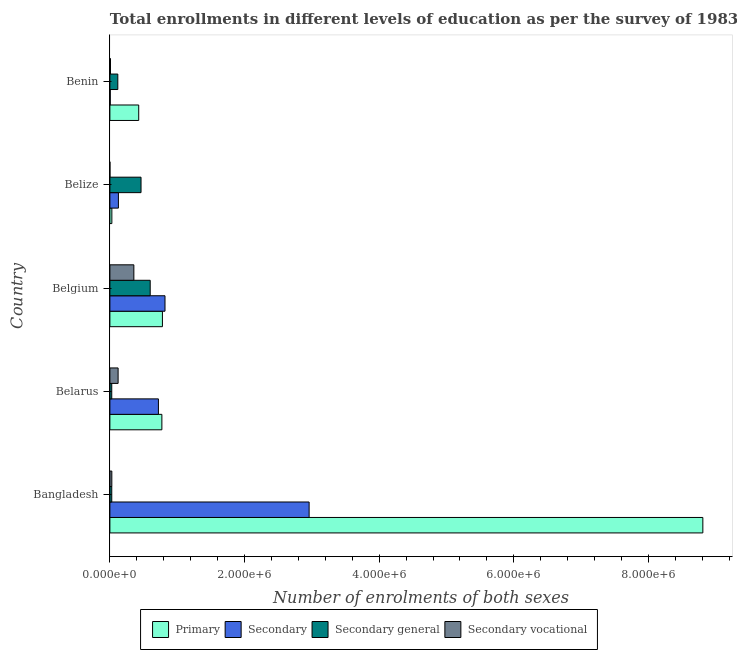Are the number of bars per tick equal to the number of legend labels?
Your answer should be compact. Yes. How many bars are there on the 3rd tick from the bottom?
Make the answer very short. 4. What is the label of the 4th group of bars from the top?
Offer a very short reply. Belarus. In how many cases, is the number of bars for a given country not equal to the number of legend labels?
Offer a terse response. 0. What is the number of enrolments in secondary education in Belgium?
Offer a very short reply. 8.19e+05. Across all countries, what is the maximum number of enrolments in secondary education?
Your answer should be very brief. 2.96e+06. Across all countries, what is the minimum number of enrolments in primary education?
Your answer should be compact. 2.91e+04. In which country was the number of enrolments in secondary general education maximum?
Give a very brief answer. Belgium. In which country was the number of enrolments in secondary education minimum?
Your answer should be compact. Benin. What is the total number of enrolments in secondary general education in the graph?
Offer a very short reply. 1.23e+06. What is the difference between the number of enrolments in secondary general education in Belize and that in Benin?
Ensure brevity in your answer.  3.45e+05. What is the difference between the number of enrolments in primary education in Bangladesh and the number of enrolments in secondary vocational education in Belgium?
Give a very brief answer. 8.45e+06. What is the average number of enrolments in secondary general education per country?
Make the answer very short. 2.47e+05. What is the difference between the number of enrolments in secondary vocational education and number of enrolments in primary education in Belize?
Provide a succinct answer. -2.89e+04. In how many countries, is the number of enrolments in secondary general education greater than 6800000 ?
Give a very brief answer. 0. What is the ratio of the number of enrolments in primary education in Bangladesh to that in Belize?
Make the answer very short. 302.47. Is the number of enrolments in secondary vocational education in Bangladesh less than that in Belarus?
Your answer should be compact. Yes. What is the difference between the highest and the second highest number of enrolments in secondary vocational education?
Make the answer very short. 2.34e+05. What is the difference between the highest and the lowest number of enrolments in secondary education?
Your answer should be very brief. 2.95e+06. In how many countries, is the number of enrolments in secondary vocational education greater than the average number of enrolments in secondary vocational education taken over all countries?
Ensure brevity in your answer.  2. Is the sum of the number of enrolments in secondary general education in Belgium and Benin greater than the maximum number of enrolments in primary education across all countries?
Offer a very short reply. No. Is it the case that in every country, the sum of the number of enrolments in secondary vocational education and number of enrolments in primary education is greater than the sum of number of enrolments in secondary education and number of enrolments in secondary general education?
Your answer should be very brief. No. What does the 4th bar from the top in Belgium represents?
Provide a short and direct response. Primary. What does the 3rd bar from the bottom in Belize represents?
Your response must be concise. Secondary general. Is it the case that in every country, the sum of the number of enrolments in primary education and number of enrolments in secondary education is greater than the number of enrolments in secondary general education?
Your answer should be very brief. No. How many countries are there in the graph?
Give a very brief answer. 5. What is the difference between two consecutive major ticks on the X-axis?
Offer a terse response. 2.00e+06. Does the graph contain any zero values?
Provide a short and direct response. No. How many legend labels are there?
Give a very brief answer. 4. What is the title of the graph?
Ensure brevity in your answer.  Total enrollments in different levels of education as per the survey of 1983. Does "Labor Taxes" appear as one of the legend labels in the graph?
Give a very brief answer. No. What is the label or title of the X-axis?
Offer a very short reply. Number of enrolments of both sexes. What is the Number of enrolments of both sexes of Primary in Bangladesh?
Your answer should be very brief. 8.81e+06. What is the Number of enrolments of both sexes in Secondary in Bangladesh?
Offer a terse response. 2.96e+06. What is the Number of enrolments of both sexes of Secondary general in Bangladesh?
Provide a succinct answer. 2.78e+04. What is the Number of enrolments of both sexes in Secondary vocational in Bangladesh?
Keep it short and to the point. 2.87e+04. What is the Number of enrolments of both sexes in Primary in Belarus?
Make the answer very short. 7.72e+05. What is the Number of enrolments of both sexes in Secondary in Belarus?
Offer a terse response. 7.21e+05. What is the Number of enrolments of both sexes in Secondary general in Belarus?
Provide a short and direct response. 2.76e+04. What is the Number of enrolments of both sexes in Secondary vocational in Belarus?
Your answer should be very brief. 1.22e+05. What is the Number of enrolments of both sexes of Primary in Belgium?
Your answer should be very brief. 7.80e+05. What is the Number of enrolments of both sexes of Secondary in Belgium?
Offer a terse response. 8.19e+05. What is the Number of enrolments of both sexes in Secondary general in Belgium?
Your answer should be compact. 5.99e+05. What is the Number of enrolments of both sexes of Secondary vocational in Belgium?
Make the answer very short. 3.56e+05. What is the Number of enrolments of both sexes of Primary in Belize?
Your answer should be compact. 2.91e+04. What is the Number of enrolments of both sexes of Secondary in Belize?
Provide a succinct answer. 1.26e+05. What is the Number of enrolments of both sexes in Secondary general in Belize?
Provide a succinct answer. 4.62e+05. What is the Number of enrolments of both sexes in Secondary vocational in Belize?
Give a very brief answer. 190. What is the Number of enrolments of both sexes in Primary in Benin?
Keep it short and to the point. 4.28e+05. What is the Number of enrolments of both sexes of Secondary in Benin?
Offer a very short reply. 5298. What is the Number of enrolments of both sexes of Secondary general in Benin?
Make the answer very short. 1.18e+05. What is the Number of enrolments of both sexes of Secondary vocational in Benin?
Your answer should be compact. 8761. Across all countries, what is the maximum Number of enrolments of both sexes in Primary?
Your response must be concise. 8.81e+06. Across all countries, what is the maximum Number of enrolments of both sexes of Secondary?
Offer a terse response. 2.96e+06. Across all countries, what is the maximum Number of enrolments of both sexes in Secondary general?
Keep it short and to the point. 5.99e+05. Across all countries, what is the maximum Number of enrolments of both sexes in Secondary vocational?
Provide a succinct answer. 3.56e+05. Across all countries, what is the minimum Number of enrolments of both sexes in Primary?
Your response must be concise. 2.91e+04. Across all countries, what is the minimum Number of enrolments of both sexes of Secondary?
Make the answer very short. 5298. Across all countries, what is the minimum Number of enrolments of both sexes in Secondary general?
Your answer should be compact. 2.76e+04. Across all countries, what is the minimum Number of enrolments of both sexes of Secondary vocational?
Your answer should be very brief. 190. What is the total Number of enrolments of both sexes of Primary in the graph?
Give a very brief answer. 1.08e+07. What is the total Number of enrolments of both sexes of Secondary in the graph?
Your answer should be very brief. 4.63e+06. What is the total Number of enrolments of both sexes in Secondary general in the graph?
Your response must be concise. 1.23e+06. What is the total Number of enrolments of both sexes of Secondary vocational in the graph?
Your answer should be very brief. 5.16e+05. What is the difference between the Number of enrolments of both sexes in Primary in Bangladesh and that in Belarus?
Make the answer very short. 8.04e+06. What is the difference between the Number of enrolments of both sexes of Secondary in Bangladesh and that in Belarus?
Offer a very short reply. 2.24e+06. What is the difference between the Number of enrolments of both sexes of Secondary general in Bangladesh and that in Belarus?
Your response must be concise. 145. What is the difference between the Number of enrolments of both sexes of Secondary vocational in Bangladesh and that in Belarus?
Give a very brief answer. -9.34e+04. What is the difference between the Number of enrolments of both sexes of Primary in Bangladesh and that in Belgium?
Your answer should be very brief. 8.03e+06. What is the difference between the Number of enrolments of both sexes in Secondary in Bangladesh and that in Belgium?
Offer a terse response. 2.14e+06. What is the difference between the Number of enrolments of both sexes of Secondary general in Bangladesh and that in Belgium?
Your response must be concise. -5.71e+05. What is the difference between the Number of enrolments of both sexes in Secondary vocational in Bangladesh and that in Belgium?
Make the answer very short. -3.27e+05. What is the difference between the Number of enrolments of both sexes of Primary in Bangladesh and that in Belize?
Offer a very short reply. 8.78e+06. What is the difference between the Number of enrolments of both sexes in Secondary in Bangladesh and that in Belize?
Your response must be concise. 2.83e+06. What is the difference between the Number of enrolments of both sexes of Secondary general in Bangladesh and that in Belize?
Your answer should be compact. -4.35e+05. What is the difference between the Number of enrolments of both sexes of Secondary vocational in Bangladesh and that in Belize?
Your response must be concise. 2.85e+04. What is the difference between the Number of enrolments of both sexes in Primary in Bangladesh and that in Benin?
Keep it short and to the point. 8.38e+06. What is the difference between the Number of enrolments of both sexes in Secondary in Bangladesh and that in Benin?
Your response must be concise. 2.95e+06. What is the difference between the Number of enrolments of both sexes of Secondary general in Bangladesh and that in Benin?
Make the answer very short. -8.99e+04. What is the difference between the Number of enrolments of both sexes of Secondary vocational in Bangladesh and that in Benin?
Make the answer very short. 1.99e+04. What is the difference between the Number of enrolments of both sexes in Primary in Belarus and that in Belgium?
Make the answer very short. -8108. What is the difference between the Number of enrolments of both sexes of Secondary in Belarus and that in Belgium?
Offer a terse response. -9.78e+04. What is the difference between the Number of enrolments of both sexes of Secondary general in Belarus and that in Belgium?
Your answer should be very brief. -5.71e+05. What is the difference between the Number of enrolments of both sexes in Secondary vocational in Belarus and that in Belgium?
Your answer should be compact. -2.34e+05. What is the difference between the Number of enrolments of both sexes of Primary in Belarus and that in Belize?
Offer a terse response. 7.43e+05. What is the difference between the Number of enrolments of both sexes in Secondary in Belarus and that in Belize?
Provide a succinct answer. 5.94e+05. What is the difference between the Number of enrolments of both sexes of Secondary general in Belarus and that in Belize?
Your answer should be very brief. -4.35e+05. What is the difference between the Number of enrolments of both sexes in Secondary vocational in Belarus and that in Belize?
Provide a short and direct response. 1.22e+05. What is the difference between the Number of enrolments of both sexes of Primary in Belarus and that in Benin?
Keep it short and to the point. 3.44e+05. What is the difference between the Number of enrolments of both sexes in Secondary in Belarus and that in Benin?
Ensure brevity in your answer.  7.16e+05. What is the difference between the Number of enrolments of both sexes of Secondary general in Belarus and that in Benin?
Your answer should be compact. -9.01e+04. What is the difference between the Number of enrolments of both sexes in Secondary vocational in Belarus and that in Benin?
Your answer should be very brief. 1.13e+05. What is the difference between the Number of enrolments of both sexes in Primary in Belgium and that in Belize?
Keep it short and to the point. 7.51e+05. What is the difference between the Number of enrolments of both sexes in Secondary in Belgium and that in Belize?
Your answer should be very brief. 6.92e+05. What is the difference between the Number of enrolments of both sexes of Secondary general in Belgium and that in Belize?
Your answer should be compact. 1.36e+05. What is the difference between the Number of enrolments of both sexes in Secondary vocational in Belgium and that in Belize?
Your response must be concise. 3.56e+05. What is the difference between the Number of enrolments of both sexes of Primary in Belgium and that in Benin?
Your answer should be compact. 3.52e+05. What is the difference between the Number of enrolments of both sexes in Secondary in Belgium and that in Benin?
Offer a very short reply. 8.13e+05. What is the difference between the Number of enrolments of both sexes of Secondary general in Belgium and that in Benin?
Offer a very short reply. 4.81e+05. What is the difference between the Number of enrolments of both sexes in Secondary vocational in Belgium and that in Benin?
Your answer should be very brief. 3.47e+05. What is the difference between the Number of enrolments of both sexes in Primary in Belize and that in Benin?
Offer a terse response. -3.99e+05. What is the difference between the Number of enrolments of both sexes of Secondary in Belize and that in Benin?
Your answer should be very brief. 1.21e+05. What is the difference between the Number of enrolments of both sexes of Secondary general in Belize and that in Benin?
Keep it short and to the point. 3.45e+05. What is the difference between the Number of enrolments of both sexes of Secondary vocational in Belize and that in Benin?
Offer a very short reply. -8571. What is the difference between the Number of enrolments of both sexes in Primary in Bangladesh and the Number of enrolments of both sexes in Secondary in Belarus?
Your response must be concise. 8.09e+06. What is the difference between the Number of enrolments of both sexes of Primary in Bangladesh and the Number of enrolments of both sexes of Secondary general in Belarus?
Give a very brief answer. 8.78e+06. What is the difference between the Number of enrolments of both sexes in Primary in Bangladesh and the Number of enrolments of both sexes in Secondary vocational in Belarus?
Give a very brief answer. 8.69e+06. What is the difference between the Number of enrolments of both sexes of Secondary in Bangladesh and the Number of enrolments of both sexes of Secondary general in Belarus?
Give a very brief answer. 2.93e+06. What is the difference between the Number of enrolments of both sexes in Secondary in Bangladesh and the Number of enrolments of both sexes in Secondary vocational in Belarus?
Provide a succinct answer. 2.84e+06. What is the difference between the Number of enrolments of both sexes in Secondary general in Bangladesh and the Number of enrolments of both sexes in Secondary vocational in Belarus?
Your response must be concise. -9.43e+04. What is the difference between the Number of enrolments of both sexes of Primary in Bangladesh and the Number of enrolments of both sexes of Secondary in Belgium?
Ensure brevity in your answer.  7.99e+06. What is the difference between the Number of enrolments of both sexes in Primary in Bangladesh and the Number of enrolments of both sexes in Secondary general in Belgium?
Offer a very short reply. 8.21e+06. What is the difference between the Number of enrolments of both sexes in Primary in Bangladesh and the Number of enrolments of both sexes in Secondary vocational in Belgium?
Offer a terse response. 8.45e+06. What is the difference between the Number of enrolments of both sexes of Secondary in Bangladesh and the Number of enrolments of both sexes of Secondary general in Belgium?
Offer a terse response. 2.36e+06. What is the difference between the Number of enrolments of both sexes of Secondary in Bangladesh and the Number of enrolments of both sexes of Secondary vocational in Belgium?
Give a very brief answer. 2.60e+06. What is the difference between the Number of enrolments of both sexes in Secondary general in Bangladesh and the Number of enrolments of both sexes in Secondary vocational in Belgium?
Provide a short and direct response. -3.28e+05. What is the difference between the Number of enrolments of both sexes of Primary in Bangladesh and the Number of enrolments of both sexes of Secondary in Belize?
Your answer should be compact. 8.68e+06. What is the difference between the Number of enrolments of both sexes in Primary in Bangladesh and the Number of enrolments of both sexes in Secondary general in Belize?
Provide a succinct answer. 8.35e+06. What is the difference between the Number of enrolments of both sexes in Primary in Bangladesh and the Number of enrolments of both sexes in Secondary vocational in Belize?
Ensure brevity in your answer.  8.81e+06. What is the difference between the Number of enrolments of both sexes in Secondary in Bangladesh and the Number of enrolments of both sexes in Secondary general in Belize?
Give a very brief answer. 2.50e+06. What is the difference between the Number of enrolments of both sexes of Secondary in Bangladesh and the Number of enrolments of both sexes of Secondary vocational in Belize?
Provide a succinct answer. 2.96e+06. What is the difference between the Number of enrolments of both sexes of Secondary general in Bangladesh and the Number of enrolments of both sexes of Secondary vocational in Belize?
Your answer should be very brief. 2.76e+04. What is the difference between the Number of enrolments of both sexes in Primary in Bangladesh and the Number of enrolments of both sexes in Secondary in Benin?
Provide a succinct answer. 8.80e+06. What is the difference between the Number of enrolments of both sexes of Primary in Bangladesh and the Number of enrolments of both sexes of Secondary general in Benin?
Ensure brevity in your answer.  8.69e+06. What is the difference between the Number of enrolments of both sexes in Primary in Bangladesh and the Number of enrolments of both sexes in Secondary vocational in Benin?
Offer a terse response. 8.80e+06. What is the difference between the Number of enrolments of both sexes in Secondary in Bangladesh and the Number of enrolments of both sexes in Secondary general in Benin?
Provide a short and direct response. 2.84e+06. What is the difference between the Number of enrolments of both sexes of Secondary in Bangladesh and the Number of enrolments of both sexes of Secondary vocational in Benin?
Offer a very short reply. 2.95e+06. What is the difference between the Number of enrolments of both sexes of Secondary general in Bangladesh and the Number of enrolments of both sexes of Secondary vocational in Benin?
Ensure brevity in your answer.  1.90e+04. What is the difference between the Number of enrolments of both sexes of Primary in Belarus and the Number of enrolments of both sexes of Secondary in Belgium?
Provide a succinct answer. -4.63e+04. What is the difference between the Number of enrolments of both sexes in Primary in Belarus and the Number of enrolments of both sexes in Secondary general in Belgium?
Your answer should be compact. 1.74e+05. What is the difference between the Number of enrolments of both sexes of Primary in Belarus and the Number of enrolments of both sexes of Secondary vocational in Belgium?
Your answer should be compact. 4.16e+05. What is the difference between the Number of enrolments of both sexes in Secondary in Belarus and the Number of enrolments of both sexes in Secondary general in Belgium?
Your answer should be compact. 1.22e+05. What is the difference between the Number of enrolments of both sexes of Secondary in Belarus and the Number of enrolments of both sexes of Secondary vocational in Belgium?
Offer a terse response. 3.65e+05. What is the difference between the Number of enrolments of both sexes in Secondary general in Belarus and the Number of enrolments of both sexes in Secondary vocational in Belgium?
Offer a very short reply. -3.28e+05. What is the difference between the Number of enrolments of both sexes of Primary in Belarus and the Number of enrolments of both sexes of Secondary in Belize?
Your response must be concise. 6.46e+05. What is the difference between the Number of enrolments of both sexes of Primary in Belarus and the Number of enrolments of both sexes of Secondary general in Belize?
Keep it short and to the point. 3.10e+05. What is the difference between the Number of enrolments of both sexes in Primary in Belarus and the Number of enrolments of both sexes in Secondary vocational in Belize?
Give a very brief answer. 7.72e+05. What is the difference between the Number of enrolments of both sexes of Secondary in Belarus and the Number of enrolments of both sexes of Secondary general in Belize?
Your answer should be compact. 2.58e+05. What is the difference between the Number of enrolments of both sexes in Secondary in Belarus and the Number of enrolments of both sexes in Secondary vocational in Belize?
Ensure brevity in your answer.  7.21e+05. What is the difference between the Number of enrolments of both sexes of Secondary general in Belarus and the Number of enrolments of both sexes of Secondary vocational in Belize?
Keep it short and to the point. 2.74e+04. What is the difference between the Number of enrolments of both sexes of Primary in Belarus and the Number of enrolments of both sexes of Secondary in Benin?
Provide a succinct answer. 7.67e+05. What is the difference between the Number of enrolments of both sexes in Primary in Belarus and the Number of enrolments of both sexes in Secondary general in Benin?
Provide a succinct answer. 6.55e+05. What is the difference between the Number of enrolments of both sexes of Primary in Belarus and the Number of enrolments of both sexes of Secondary vocational in Benin?
Give a very brief answer. 7.64e+05. What is the difference between the Number of enrolments of both sexes of Secondary in Belarus and the Number of enrolments of both sexes of Secondary general in Benin?
Your response must be concise. 6.03e+05. What is the difference between the Number of enrolments of both sexes in Secondary in Belarus and the Number of enrolments of both sexes in Secondary vocational in Benin?
Offer a terse response. 7.12e+05. What is the difference between the Number of enrolments of both sexes of Secondary general in Belarus and the Number of enrolments of both sexes of Secondary vocational in Benin?
Your response must be concise. 1.89e+04. What is the difference between the Number of enrolments of both sexes of Primary in Belgium and the Number of enrolments of both sexes of Secondary in Belize?
Provide a succinct answer. 6.54e+05. What is the difference between the Number of enrolments of both sexes in Primary in Belgium and the Number of enrolments of both sexes in Secondary general in Belize?
Ensure brevity in your answer.  3.18e+05. What is the difference between the Number of enrolments of both sexes in Primary in Belgium and the Number of enrolments of both sexes in Secondary vocational in Belize?
Offer a very short reply. 7.80e+05. What is the difference between the Number of enrolments of both sexes in Secondary in Belgium and the Number of enrolments of both sexes in Secondary general in Belize?
Offer a terse response. 3.56e+05. What is the difference between the Number of enrolments of both sexes in Secondary in Belgium and the Number of enrolments of both sexes in Secondary vocational in Belize?
Offer a terse response. 8.18e+05. What is the difference between the Number of enrolments of both sexes of Secondary general in Belgium and the Number of enrolments of both sexes of Secondary vocational in Belize?
Ensure brevity in your answer.  5.99e+05. What is the difference between the Number of enrolments of both sexes in Primary in Belgium and the Number of enrolments of both sexes in Secondary in Benin?
Your answer should be compact. 7.75e+05. What is the difference between the Number of enrolments of both sexes in Primary in Belgium and the Number of enrolments of both sexes in Secondary general in Benin?
Provide a succinct answer. 6.63e+05. What is the difference between the Number of enrolments of both sexes of Primary in Belgium and the Number of enrolments of both sexes of Secondary vocational in Benin?
Make the answer very short. 7.72e+05. What is the difference between the Number of enrolments of both sexes of Secondary in Belgium and the Number of enrolments of both sexes of Secondary general in Benin?
Make the answer very short. 7.01e+05. What is the difference between the Number of enrolments of both sexes of Secondary in Belgium and the Number of enrolments of both sexes of Secondary vocational in Benin?
Provide a short and direct response. 8.10e+05. What is the difference between the Number of enrolments of both sexes in Secondary general in Belgium and the Number of enrolments of both sexes in Secondary vocational in Benin?
Give a very brief answer. 5.90e+05. What is the difference between the Number of enrolments of both sexes of Primary in Belize and the Number of enrolments of both sexes of Secondary in Benin?
Provide a short and direct response. 2.38e+04. What is the difference between the Number of enrolments of both sexes in Primary in Belize and the Number of enrolments of both sexes in Secondary general in Benin?
Your response must be concise. -8.86e+04. What is the difference between the Number of enrolments of both sexes in Primary in Belize and the Number of enrolments of both sexes in Secondary vocational in Benin?
Your response must be concise. 2.04e+04. What is the difference between the Number of enrolments of both sexes in Secondary in Belize and the Number of enrolments of both sexes in Secondary general in Benin?
Make the answer very short. 8761. What is the difference between the Number of enrolments of both sexes of Secondary in Belize and the Number of enrolments of both sexes of Secondary vocational in Benin?
Make the answer very short. 1.18e+05. What is the difference between the Number of enrolments of both sexes of Secondary general in Belize and the Number of enrolments of both sexes of Secondary vocational in Benin?
Offer a very short reply. 4.54e+05. What is the average Number of enrolments of both sexes of Primary per country?
Offer a very short reply. 2.16e+06. What is the average Number of enrolments of both sexes of Secondary per country?
Make the answer very short. 9.26e+05. What is the average Number of enrolments of both sexes of Secondary general per country?
Your answer should be compact. 2.47e+05. What is the average Number of enrolments of both sexes of Secondary vocational per country?
Ensure brevity in your answer.  1.03e+05. What is the difference between the Number of enrolments of both sexes in Primary and Number of enrolments of both sexes in Secondary in Bangladesh?
Provide a succinct answer. 5.85e+06. What is the difference between the Number of enrolments of both sexes in Primary and Number of enrolments of both sexes in Secondary general in Bangladesh?
Ensure brevity in your answer.  8.78e+06. What is the difference between the Number of enrolments of both sexes in Primary and Number of enrolments of both sexes in Secondary vocational in Bangladesh?
Provide a short and direct response. 8.78e+06. What is the difference between the Number of enrolments of both sexes in Secondary and Number of enrolments of both sexes in Secondary general in Bangladesh?
Offer a very short reply. 2.93e+06. What is the difference between the Number of enrolments of both sexes in Secondary and Number of enrolments of both sexes in Secondary vocational in Bangladesh?
Keep it short and to the point. 2.93e+06. What is the difference between the Number of enrolments of both sexes of Secondary general and Number of enrolments of both sexes of Secondary vocational in Bangladesh?
Provide a short and direct response. -895. What is the difference between the Number of enrolments of both sexes of Primary and Number of enrolments of both sexes of Secondary in Belarus?
Make the answer very short. 5.15e+04. What is the difference between the Number of enrolments of both sexes in Primary and Number of enrolments of both sexes in Secondary general in Belarus?
Ensure brevity in your answer.  7.45e+05. What is the difference between the Number of enrolments of both sexes of Primary and Number of enrolments of both sexes of Secondary vocational in Belarus?
Offer a terse response. 6.50e+05. What is the difference between the Number of enrolments of both sexes in Secondary and Number of enrolments of both sexes in Secondary general in Belarus?
Your answer should be compact. 6.93e+05. What is the difference between the Number of enrolments of both sexes of Secondary and Number of enrolments of both sexes of Secondary vocational in Belarus?
Make the answer very short. 5.99e+05. What is the difference between the Number of enrolments of both sexes of Secondary general and Number of enrolments of both sexes of Secondary vocational in Belarus?
Provide a short and direct response. -9.45e+04. What is the difference between the Number of enrolments of both sexes of Primary and Number of enrolments of both sexes of Secondary in Belgium?
Keep it short and to the point. -3.82e+04. What is the difference between the Number of enrolments of both sexes in Primary and Number of enrolments of both sexes in Secondary general in Belgium?
Your answer should be compact. 1.82e+05. What is the difference between the Number of enrolments of both sexes in Primary and Number of enrolments of both sexes in Secondary vocational in Belgium?
Provide a succinct answer. 4.24e+05. What is the difference between the Number of enrolments of both sexes of Secondary and Number of enrolments of both sexes of Secondary general in Belgium?
Provide a short and direct response. 2.20e+05. What is the difference between the Number of enrolments of both sexes in Secondary and Number of enrolments of both sexes in Secondary vocational in Belgium?
Offer a very short reply. 4.62e+05. What is the difference between the Number of enrolments of both sexes in Secondary general and Number of enrolments of both sexes in Secondary vocational in Belgium?
Offer a terse response. 2.43e+05. What is the difference between the Number of enrolments of both sexes of Primary and Number of enrolments of both sexes of Secondary in Belize?
Ensure brevity in your answer.  -9.74e+04. What is the difference between the Number of enrolments of both sexes in Primary and Number of enrolments of both sexes in Secondary general in Belize?
Provide a succinct answer. -4.33e+05. What is the difference between the Number of enrolments of both sexes in Primary and Number of enrolments of both sexes in Secondary vocational in Belize?
Provide a succinct answer. 2.89e+04. What is the difference between the Number of enrolments of both sexes in Secondary and Number of enrolments of both sexes in Secondary general in Belize?
Ensure brevity in your answer.  -3.36e+05. What is the difference between the Number of enrolments of both sexes of Secondary and Number of enrolments of both sexes of Secondary vocational in Belize?
Offer a terse response. 1.26e+05. What is the difference between the Number of enrolments of both sexes in Secondary general and Number of enrolments of both sexes in Secondary vocational in Belize?
Offer a very short reply. 4.62e+05. What is the difference between the Number of enrolments of both sexes of Primary and Number of enrolments of both sexes of Secondary in Benin?
Make the answer very short. 4.23e+05. What is the difference between the Number of enrolments of both sexes of Primary and Number of enrolments of both sexes of Secondary general in Benin?
Provide a short and direct response. 3.10e+05. What is the difference between the Number of enrolments of both sexes in Primary and Number of enrolments of both sexes in Secondary vocational in Benin?
Make the answer very short. 4.19e+05. What is the difference between the Number of enrolments of both sexes in Secondary and Number of enrolments of both sexes in Secondary general in Benin?
Offer a very short reply. -1.12e+05. What is the difference between the Number of enrolments of both sexes in Secondary and Number of enrolments of both sexes in Secondary vocational in Benin?
Give a very brief answer. -3463. What is the difference between the Number of enrolments of both sexes of Secondary general and Number of enrolments of both sexes of Secondary vocational in Benin?
Keep it short and to the point. 1.09e+05. What is the ratio of the Number of enrolments of both sexes in Primary in Bangladesh to that in Belarus?
Offer a very short reply. 11.4. What is the ratio of the Number of enrolments of both sexes in Secondary in Bangladesh to that in Belarus?
Offer a terse response. 4.11. What is the ratio of the Number of enrolments of both sexes in Secondary vocational in Bangladesh to that in Belarus?
Provide a succinct answer. 0.23. What is the ratio of the Number of enrolments of both sexes of Primary in Bangladesh to that in Belgium?
Your response must be concise. 11.29. What is the ratio of the Number of enrolments of both sexes in Secondary in Bangladesh to that in Belgium?
Your answer should be very brief. 3.62. What is the ratio of the Number of enrolments of both sexes in Secondary general in Bangladesh to that in Belgium?
Provide a short and direct response. 0.05. What is the ratio of the Number of enrolments of both sexes in Secondary vocational in Bangladesh to that in Belgium?
Keep it short and to the point. 0.08. What is the ratio of the Number of enrolments of both sexes in Primary in Bangladesh to that in Belize?
Make the answer very short. 302.47. What is the ratio of the Number of enrolments of both sexes of Secondary in Bangladesh to that in Belize?
Your response must be concise. 23.4. What is the ratio of the Number of enrolments of both sexes in Secondary general in Bangladesh to that in Belize?
Provide a succinct answer. 0.06. What is the ratio of the Number of enrolments of both sexes in Secondary vocational in Bangladesh to that in Belize?
Your answer should be compact. 150.95. What is the ratio of the Number of enrolments of both sexes in Primary in Bangladesh to that in Benin?
Make the answer very short. 20.57. What is the ratio of the Number of enrolments of both sexes of Secondary in Bangladesh to that in Benin?
Your response must be concise. 558.6. What is the ratio of the Number of enrolments of both sexes in Secondary general in Bangladesh to that in Benin?
Make the answer very short. 0.24. What is the ratio of the Number of enrolments of both sexes in Secondary vocational in Bangladesh to that in Benin?
Your answer should be compact. 3.27. What is the ratio of the Number of enrolments of both sexes of Secondary in Belarus to that in Belgium?
Provide a short and direct response. 0.88. What is the ratio of the Number of enrolments of both sexes in Secondary general in Belarus to that in Belgium?
Your answer should be very brief. 0.05. What is the ratio of the Number of enrolments of both sexes in Secondary vocational in Belarus to that in Belgium?
Offer a very short reply. 0.34. What is the ratio of the Number of enrolments of both sexes of Primary in Belarus to that in Belize?
Make the answer very short. 26.52. What is the ratio of the Number of enrolments of both sexes of Secondary in Belarus to that in Belize?
Ensure brevity in your answer.  5.7. What is the ratio of the Number of enrolments of both sexes of Secondary general in Belarus to that in Belize?
Offer a terse response. 0.06. What is the ratio of the Number of enrolments of both sexes of Secondary vocational in Belarus to that in Belize?
Offer a terse response. 642.63. What is the ratio of the Number of enrolments of both sexes in Primary in Belarus to that in Benin?
Make the answer very short. 1.8. What is the ratio of the Number of enrolments of both sexes of Secondary in Belarus to that in Benin?
Your answer should be compact. 136.05. What is the ratio of the Number of enrolments of both sexes in Secondary general in Belarus to that in Benin?
Your response must be concise. 0.23. What is the ratio of the Number of enrolments of both sexes in Secondary vocational in Belarus to that in Benin?
Offer a very short reply. 13.94. What is the ratio of the Number of enrolments of both sexes in Primary in Belgium to that in Belize?
Ensure brevity in your answer.  26.8. What is the ratio of the Number of enrolments of both sexes of Secondary in Belgium to that in Belize?
Ensure brevity in your answer.  6.47. What is the ratio of the Number of enrolments of both sexes of Secondary general in Belgium to that in Belize?
Keep it short and to the point. 1.29. What is the ratio of the Number of enrolments of both sexes of Secondary vocational in Belgium to that in Belize?
Provide a succinct answer. 1874.32. What is the ratio of the Number of enrolments of both sexes of Primary in Belgium to that in Benin?
Provide a succinct answer. 1.82. What is the ratio of the Number of enrolments of both sexes in Secondary in Belgium to that in Benin?
Offer a very short reply. 154.51. What is the ratio of the Number of enrolments of both sexes of Secondary general in Belgium to that in Benin?
Your answer should be compact. 5.09. What is the ratio of the Number of enrolments of both sexes in Secondary vocational in Belgium to that in Benin?
Make the answer very short. 40.65. What is the ratio of the Number of enrolments of both sexes in Primary in Belize to that in Benin?
Your response must be concise. 0.07. What is the ratio of the Number of enrolments of both sexes of Secondary in Belize to that in Benin?
Your response must be concise. 23.87. What is the ratio of the Number of enrolments of both sexes in Secondary general in Belize to that in Benin?
Make the answer very short. 3.93. What is the ratio of the Number of enrolments of both sexes of Secondary vocational in Belize to that in Benin?
Provide a short and direct response. 0.02. What is the difference between the highest and the second highest Number of enrolments of both sexes of Primary?
Make the answer very short. 8.03e+06. What is the difference between the highest and the second highest Number of enrolments of both sexes of Secondary?
Provide a succinct answer. 2.14e+06. What is the difference between the highest and the second highest Number of enrolments of both sexes in Secondary general?
Ensure brevity in your answer.  1.36e+05. What is the difference between the highest and the second highest Number of enrolments of both sexes in Secondary vocational?
Your response must be concise. 2.34e+05. What is the difference between the highest and the lowest Number of enrolments of both sexes in Primary?
Provide a succinct answer. 8.78e+06. What is the difference between the highest and the lowest Number of enrolments of both sexes in Secondary?
Give a very brief answer. 2.95e+06. What is the difference between the highest and the lowest Number of enrolments of both sexes of Secondary general?
Give a very brief answer. 5.71e+05. What is the difference between the highest and the lowest Number of enrolments of both sexes in Secondary vocational?
Provide a succinct answer. 3.56e+05. 